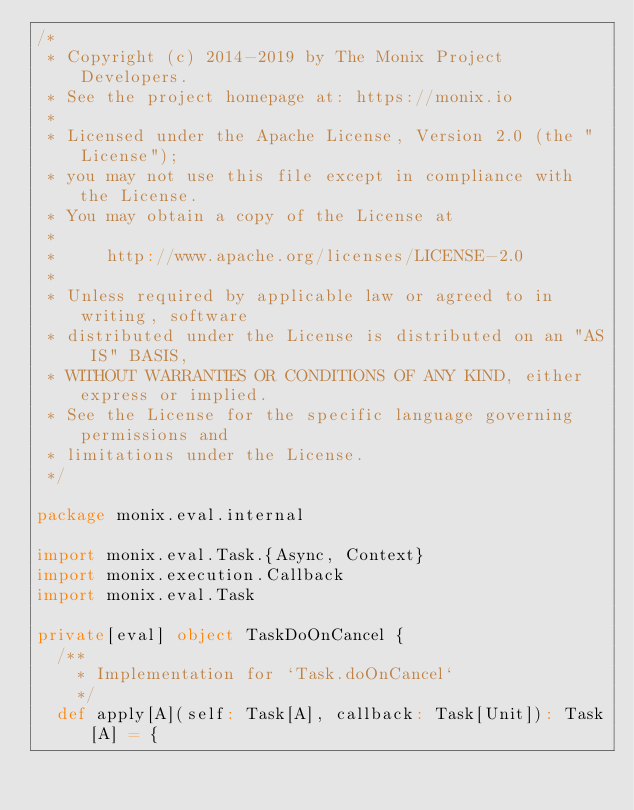<code> <loc_0><loc_0><loc_500><loc_500><_Scala_>/*
 * Copyright (c) 2014-2019 by The Monix Project Developers.
 * See the project homepage at: https://monix.io
 *
 * Licensed under the Apache License, Version 2.0 (the "License");
 * you may not use this file except in compliance with the License.
 * You may obtain a copy of the License at
 *
 *     http://www.apache.org/licenses/LICENSE-2.0
 *
 * Unless required by applicable law or agreed to in writing, software
 * distributed under the License is distributed on an "AS IS" BASIS,
 * WITHOUT WARRANTIES OR CONDITIONS OF ANY KIND, either express or implied.
 * See the License for the specific language governing permissions and
 * limitations under the License.
 */

package monix.eval.internal

import monix.eval.Task.{Async, Context}
import monix.execution.Callback
import monix.eval.Task

private[eval] object TaskDoOnCancel {
  /**
    * Implementation for `Task.doOnCancel`
    */
  def apply[A](self: Task[A], callback: Task[Unit]): Task[A] = {</code> 